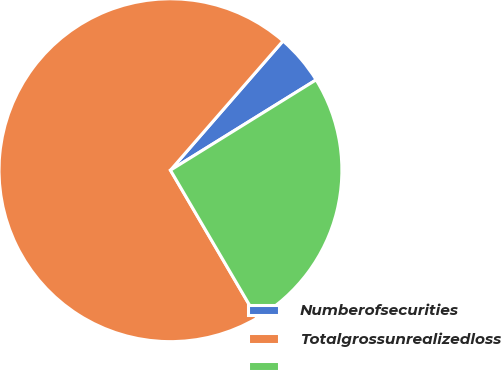<chart> <loc_0><loc_0><loc_500><loc_500><pie_chart><fcel>Numberofsecurities<fcel>Totalgrossunrealizedloss<fcel>Unnamed: 2<nl><fcel>4.76%<fcel>69.84%<fcel>25.4%<nl></chart> 